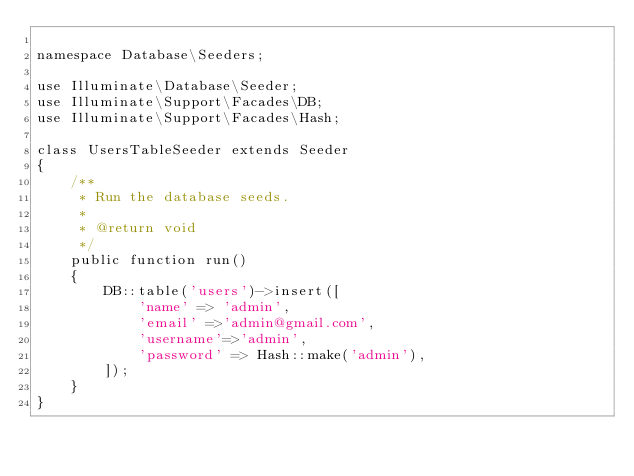Convert code to text. <code><loc_0><loc_0><loc_500><loc_500><_PHP_>
namespace Database\Seeders;

use Illuminate\Database\Seeder;
use Illuminate\Support\Facades\DB;
use Illuminate\Support\Facades\Hash;

class UsersTableSeeder extends Seeder
{
    /**
     * Run the database seeds.
     *
     * @return void
     */
    public function run()
    {
        DB::table('users')->insert([
            'name' => 'admin',
            'email' =>'admin@gmail.com',
            'username'=>'admin',
            'password' => Hash::make('admin'),
        ]);
    }
}
</code> 